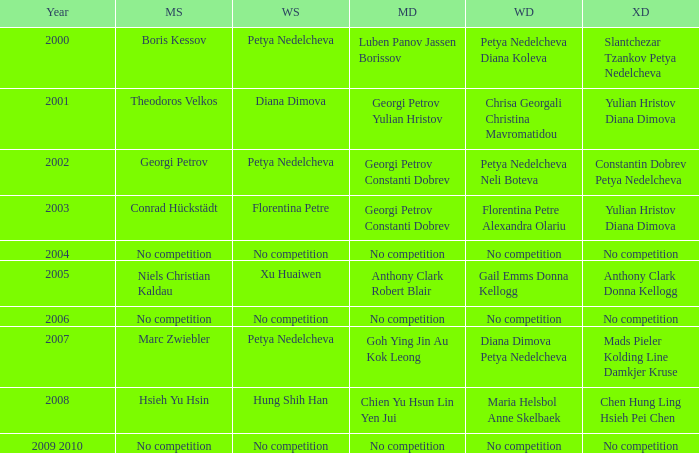What is the year when Conrad Hückstädt won Men's Single? 2003.0. 